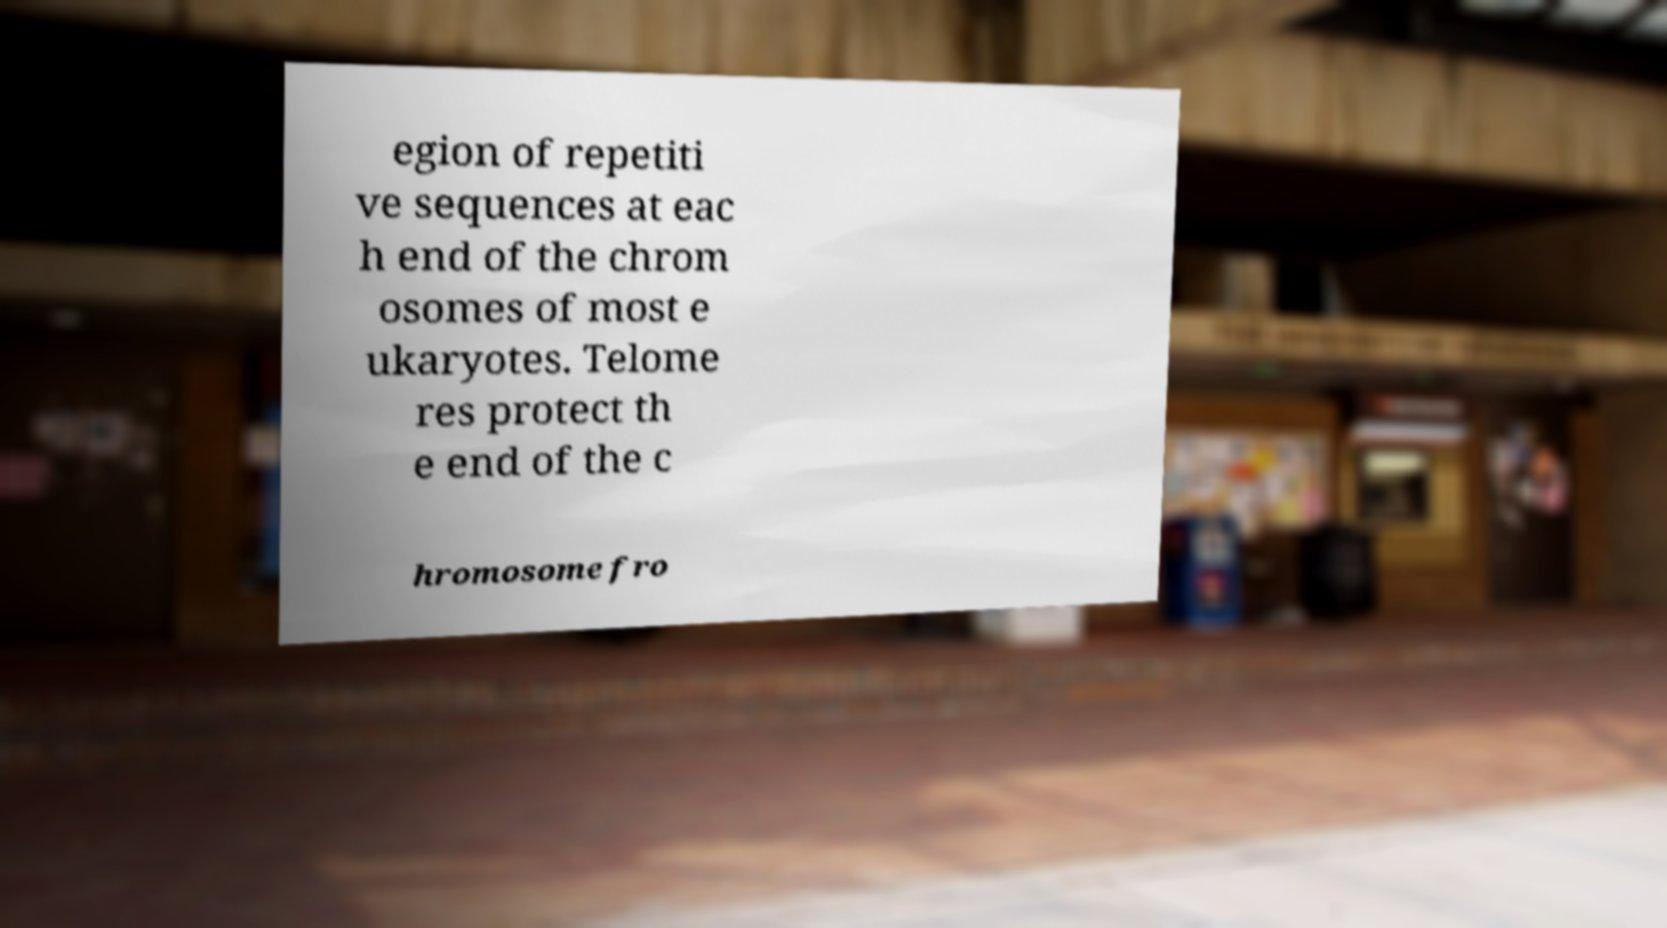Can you read and provide the text displayed in the image?This photo seems to have some interesting text. Can you extract and type it out for me? egion of repetiti ve sequences at eac h end of the chrom osomes of most e ukaryotes. Telome res protect th e end of the c hromosome fro 